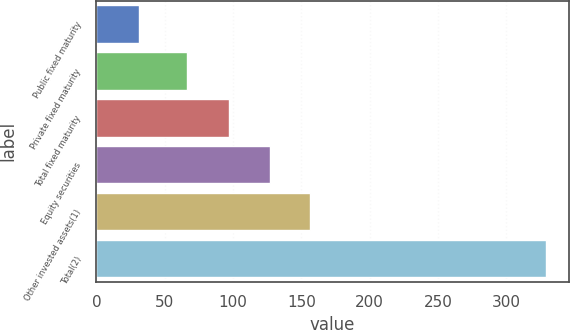Convert chart. <chart><loc_0><loc_0><loc_500><loc_500><bar_chart><fcel>Public fixed maturity<fcel>Private fixed maturity<fcel>Total fixed maturity<fcel>Equity securities<fcel>Other invested assets(1)<fcel>Total(2)<nl><fcel>31<fcel>66<fcel>97<fcel>126.8<fcel>156.6<fcel>329<nl></chart> 